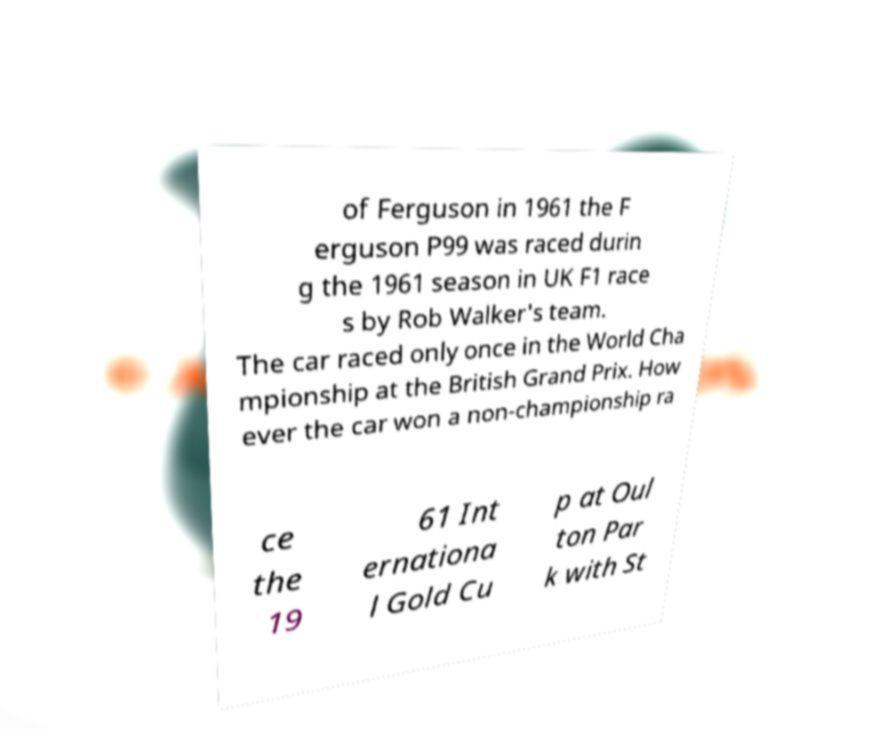Can you accurately transcribe the text from the provided image for me? of Ferguson in 1961 the F erguson P99 was raced durin g the 1961 season in UK F1 race s by Rob Walker's team. The car raced only once in the World Cha mpionship at the British Grand Prix. How ever the car won a non-championship ra ce the 19 61 Int ernationa l Gold Cu p at Oul ton Par k with St 